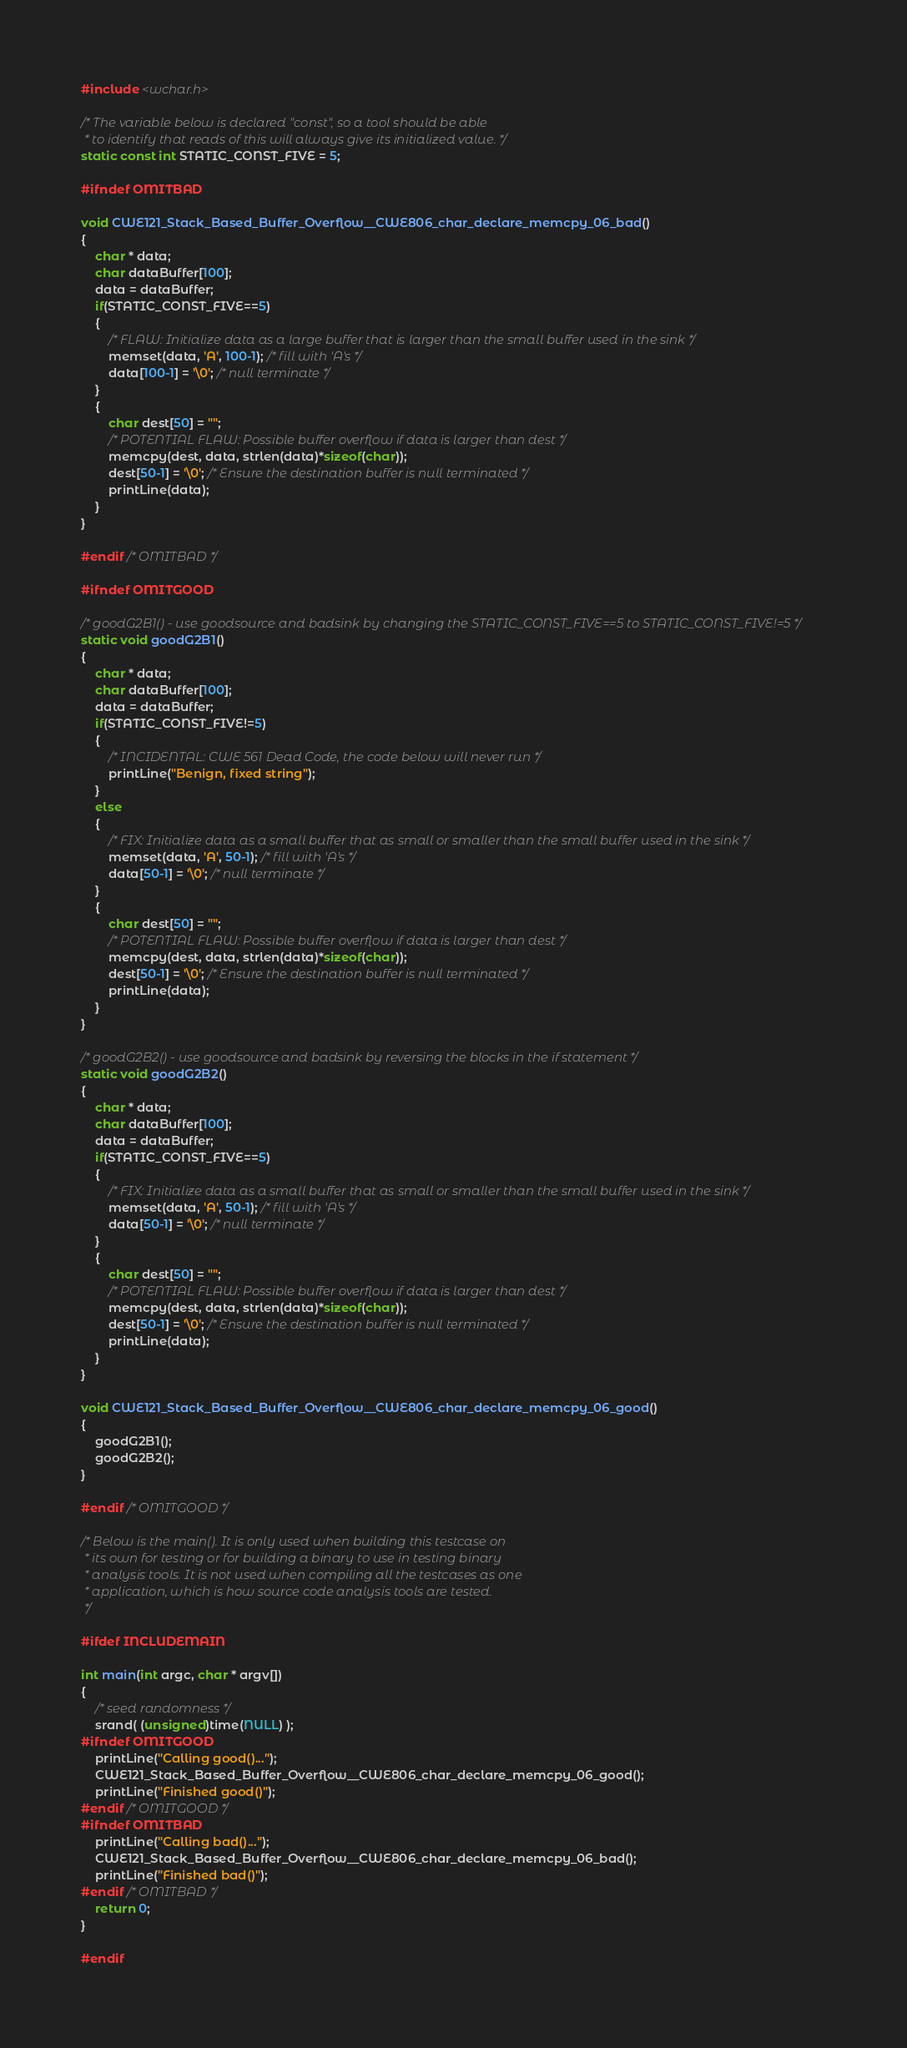<code> <loc_0><loc_0><loc_500><loc_500><_C_>#include <wchar.h>

/* The variable below is declared "const", so a tool should be able
 * to identify that reads of this will always give its initialized value. */
static const int STATIC_CONST_FIVE = 5;

#ifndef OMITBAD

void CWE121_Stack_Based_Buffer_Overflow__CWE806_char_declare_memcpy_06_bad()
{
    char * data;
    char dataBuffer[100];
    data = dataBuffer;
    if(STATIC_CONST_FIVE==5)
    {
        /* FLAW: Initialize data as a large buffer that is larger than the small buffer used in the sink */
        memset(data, 'A', 100-1); /* fill with 'A's */
        data[100-1] = '\0'; /* null terminate */
    }
    {
        char dest[50] = "";
        /* POTENTIAL FLAW: Possible buffer overflow if data is larger than dest */
        memcpy(dest, data, strlen(data)*sizeof(char));
        dest[50-1] = '\0'; /* Ensure the destination buffer is null terminated */
        printLine(data);
    }
}

#endif /* OMITBAD */

#ifndef OMITGOOD

/* goodG2B1() - use goodsource and badsink by changing the STATIC_CONST_FIVE==5 to STATIC_CONST_FIVE!=5 */
static void goodG2B1()
{
    char * data;
    char dataBuffer[100];
    data = dataBuffer;
    if(STATIC_CONST_FIVE!=5)
    {
        /* INCIDENTAL: CWE 561 Dead Code, the code below will never run */
        printLine("Benign, fixed string");
    }
    else
    {
        /* FIX: Initialize data as a small buffer that as small or smaller than the small buffer used in the sink */
        memset(data, 'A', 50-1); /* fill with 'A's */
        data[50-1] = '\0'; /* null terminate */
    }
    {
        char dest[50] = "";
        /* POTENTIAL FLAW: Possible buffer overflow if data is larger than dest */
        memcpy(dest, data, strlen(data)*sizeof(char));
        dest[50-1] = '\0'; /* Ensure the destination buffer is null terminated */
        printLine(data);
    }
}

/* goodG2B2() - use goodsource and badsink by reversing the blocks in the if statement */
static void goodG2B2()
{
    char * data;
    char dataBuffer[100];
    data = dataBuffer;
    if(STATIC_CONST_FIVE==5)
    {
        /* FIX: Initialize data as a small buffer that as small or smaller than the small buffer used in the sink */
        memset(data, 'A', 50-1); /* fill with 'A's */
        data[50-1] = '\0'; /* null terminate */
    }
    {
        char dest[50] = "";
        /* POTENTIAL FLAW: Possible buffer overflow if data is larger than dest */
        memcpy(dest, data, strlen(data)*sizeof(char));
        dest[50-1] = '\0'; /* Ensure the destination buffer is null terminated */
        printLine(data);
    }
}

void CWE121_Stack_Based_Buffer_Overflow__CWE806_char_declare_memcpy_06_good()
{
    goodG2B1();
    goodG2B2();
}

#endif /* OMITGOOD */

/* Below is the main(). It is only used when building this testcase on
 * its own for testing or for building a binary to use in testing binary
 * analysis tools. It is not used when compiling all the testcases as one
 * application, which is how source code analysis tools are tested.
 */

#ifdef INCLUDEMAIN

int main(int argc, char * argv[])
{
    /* seed randomness */
    srand( (unsigned)time(NULL) );
#ifndef OMITGOOD
    printLine("Calling good()...");
    CWE121_Stack_Based_Buffer_Overflow__CWE806_char_declare_memcpy_06_good();
    printLine("Finished good()");
#endif /* OMITGOOD */
#ifndef OMITBAD
    printLine("Calling bad()...");
    CWE121_Stack_Based_Buffer_Overflow__CWE806_char_declare_memcpy_06_bad();
    printLine("Finished bad()");
#endif /* OMITBAD */
    return 0;
}

#endif
</code> 